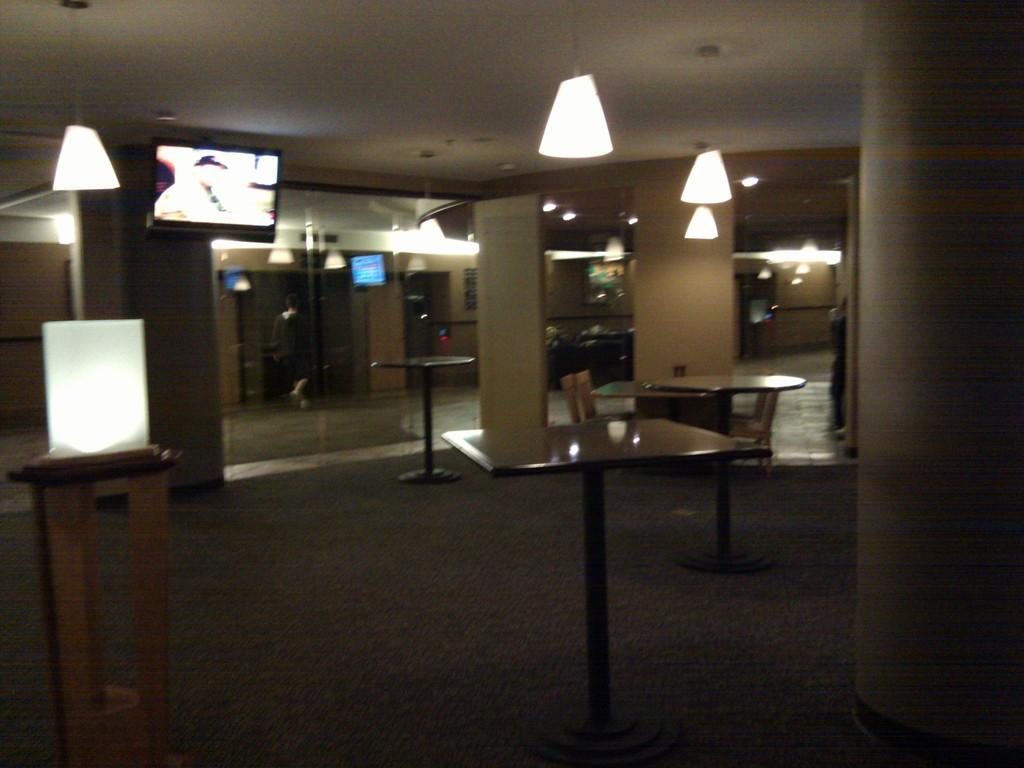What type of architectural feature can be seen in the image? There are pillars in the image. What can be used for illumination in the image? There are lights in the image. What might be used for displaying items or supporting objects in the image? There are stands in the image. What is present on the wall in the image? There are screens on the wall in the image. What can be seen in the background of the image? There are objects visible in the background of the image. What type of gardening tool is being used by the person in the image? There is no person or gardening tool present in the image. What type of drug is being administered to the person in the image? There is no person or drug present in the image. 